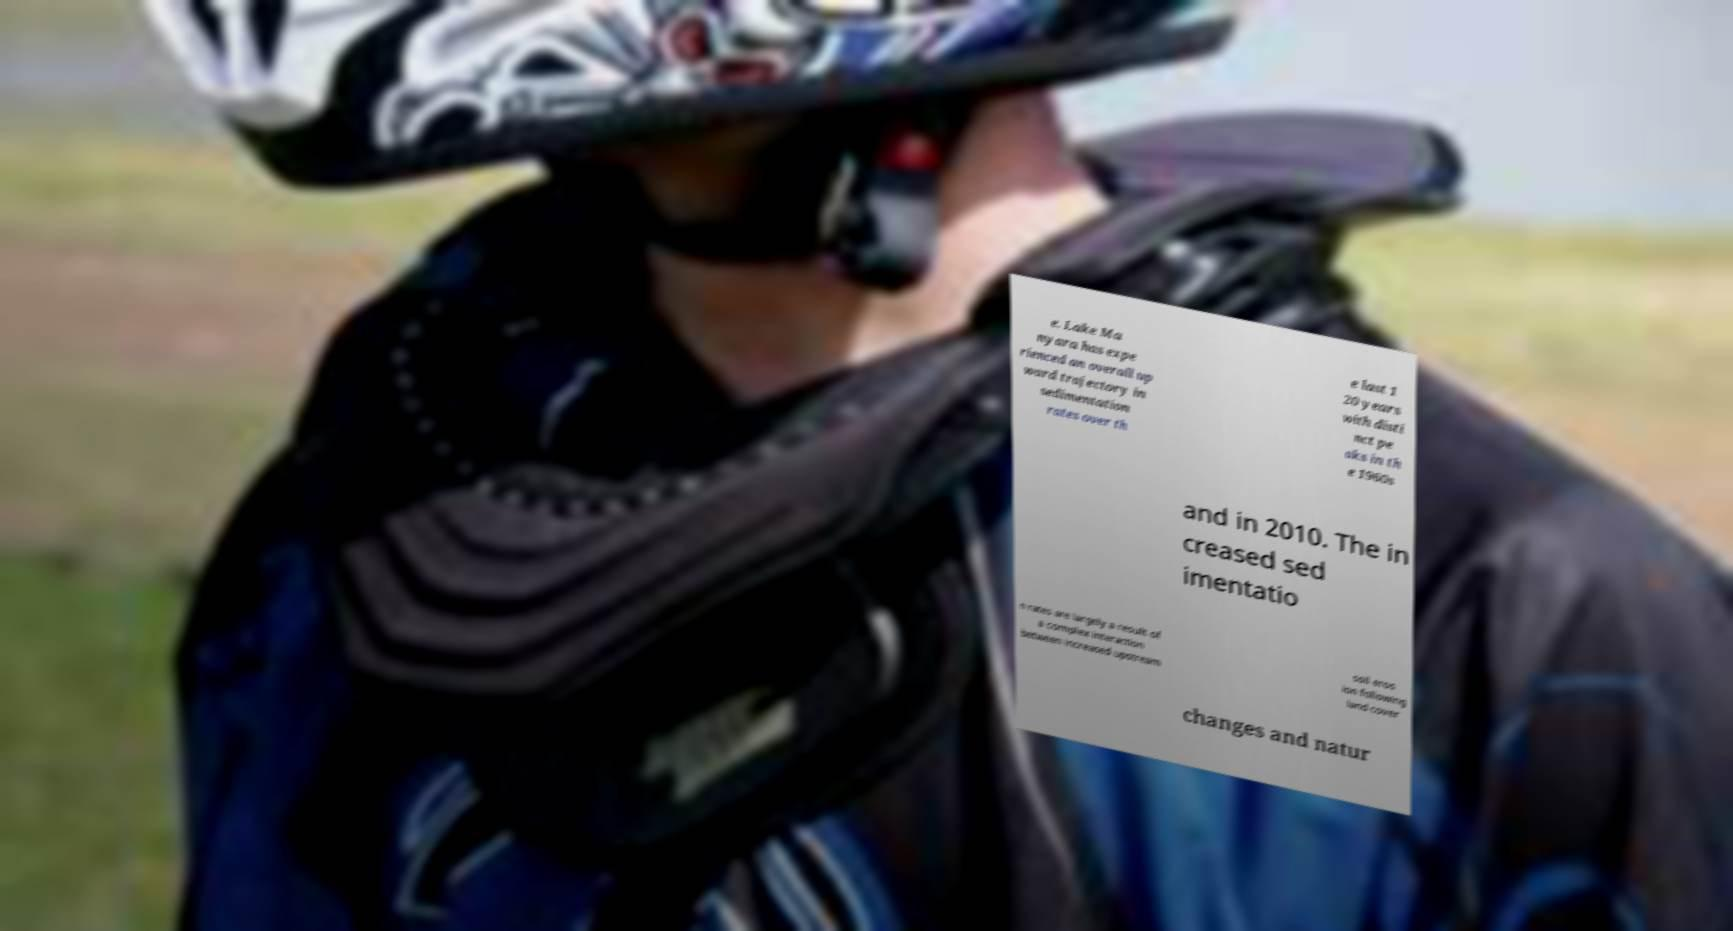There's text embedded in this image that I need extracted. Can you transcribe it verbatim? e. Lake Ma nyara has expe rienced an overall up ward trajectory in sedimentation rates over th e last 1 20 years with disti nct pe aks in th e 1960s and in 2010. The in creased sed imentatio n rates are largely a result of a complex interaction between increased upstream soil eros ion following land cover changes and natur 